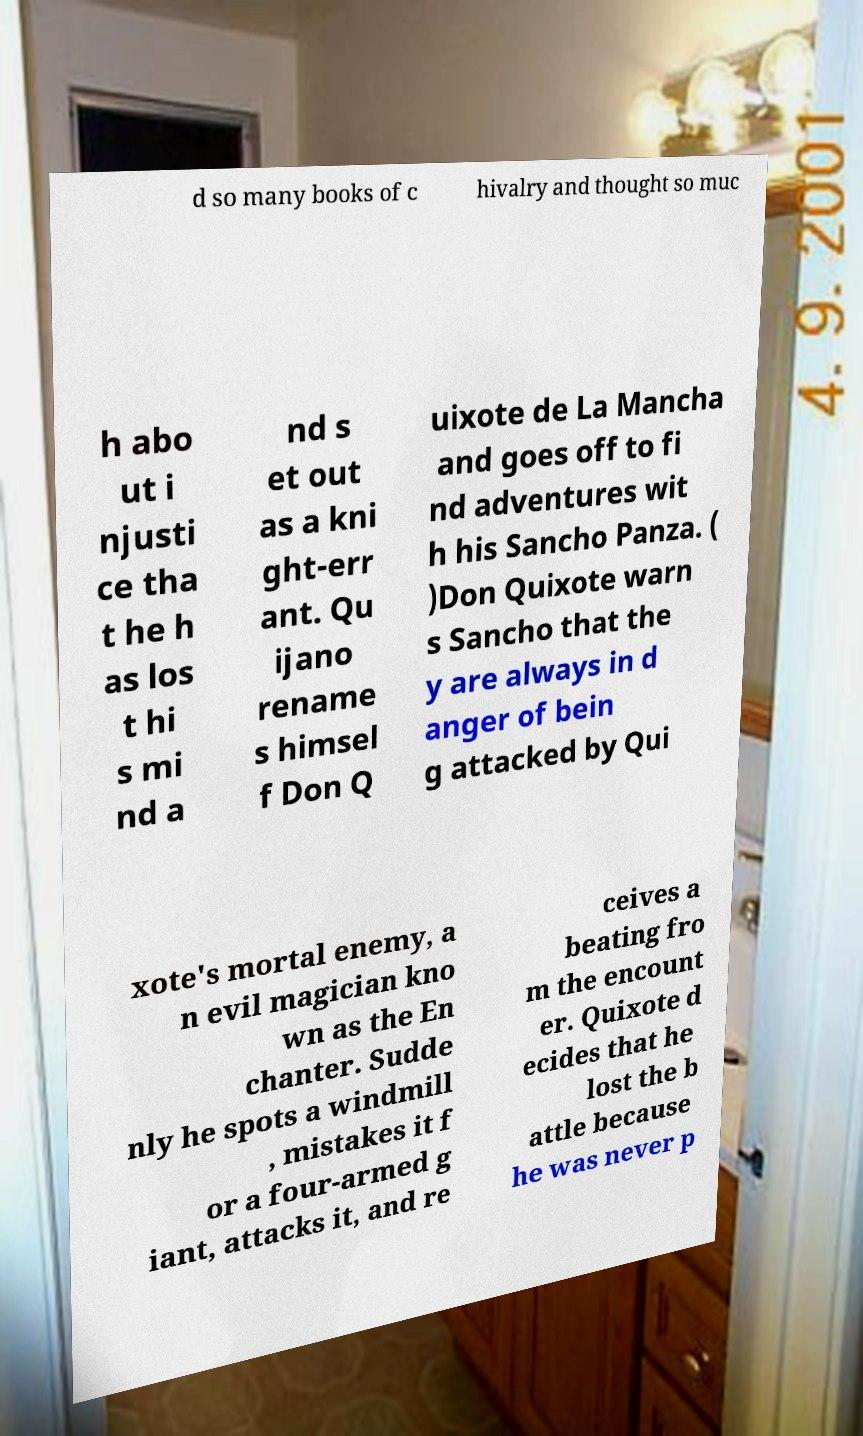Please read and relay the text visible in this image. What does it say? d so many books of c hivalry and thought so muc h abo ut i njusti ce tha t he h as los t hi s mi nd a nd s et out as a kni ght-err ant. Qu ijano rename s himsel f Don Q uixote de La Mancha and goes off to fi nd adventures wit h his Sancho Panza. ( )Don Quixote warn s Sancho that the y are always in d anger of bein g attacked by Qui xote's mortal enemy, a n evil magician kno wn as the En chanter. Sudde nly he spots a windmill , mistakes it f or a four-armed g iant, attacks it, and re ceives a beating fro m the encount er. Quixote d ecides that he lost the b attle because he was never p 